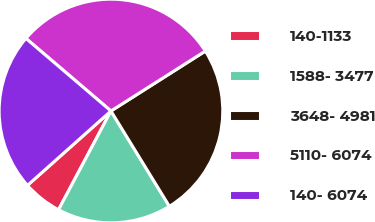Convert chart to OTSL. <chart><loc_0><loc_0><loc_500><loc_500><pie_chart><fcel>140-1133<fcel>1588- 3477<fcel>3648- 4981<fcel>5110- 6074<fcel>140- 6074<nl><fcel>5.65%<fcel>16.52%<fcel>25.25%<fcel>29.75%<fcel>22.83%<nl></chart> 